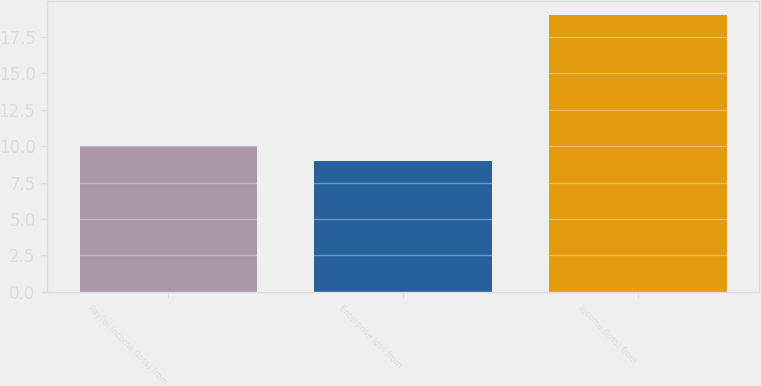Convert chart to OTSL. <chart><loc_0><loc_0><loc_500><loc_500><bar_chart><fcel>PayPal income (loss) from<fcel>Enterprise loss from<fcel>Income (loss) from<nl><fcel>10<fcel>9<fcel>19<nl></chart> 